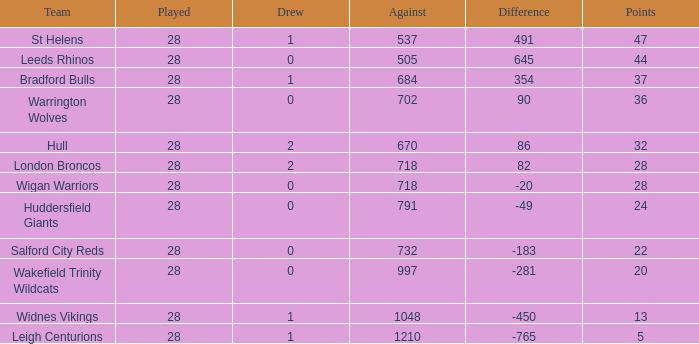What is the most lost games for the team with a difference smaller than 86 and points of 32? None. 